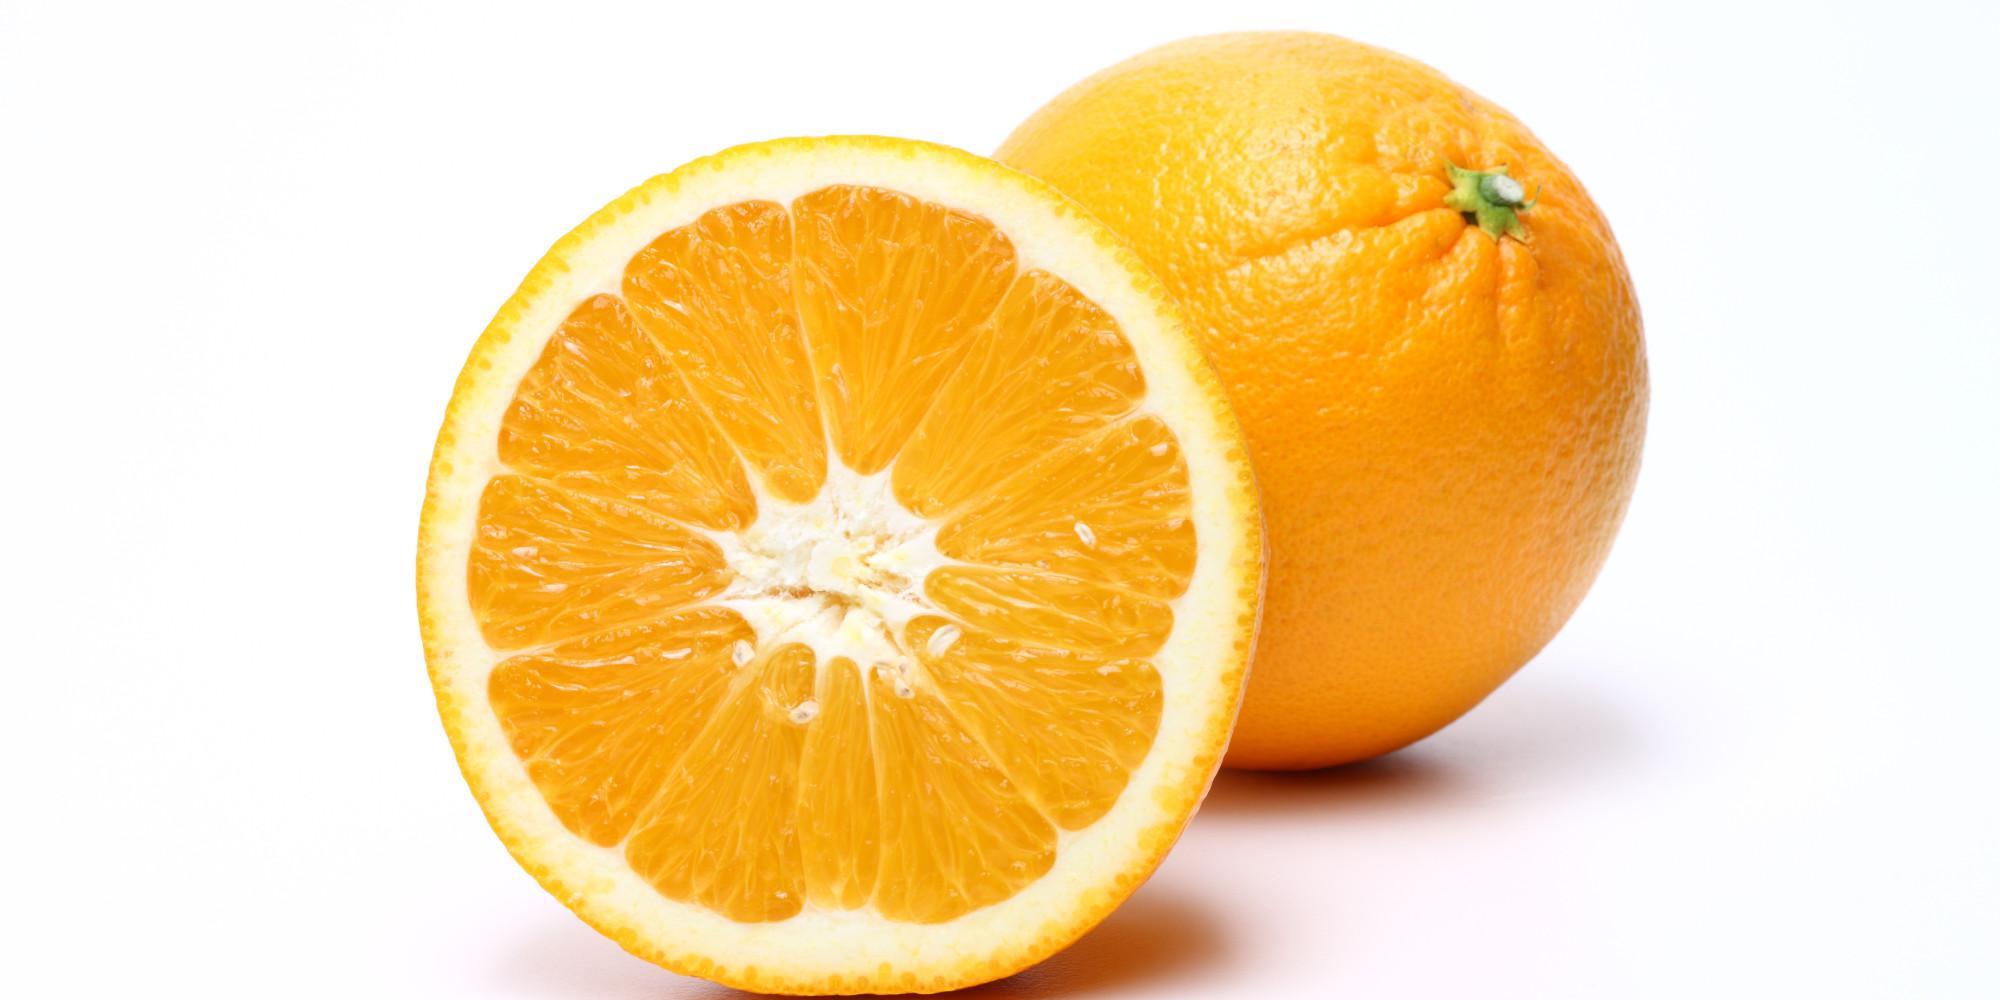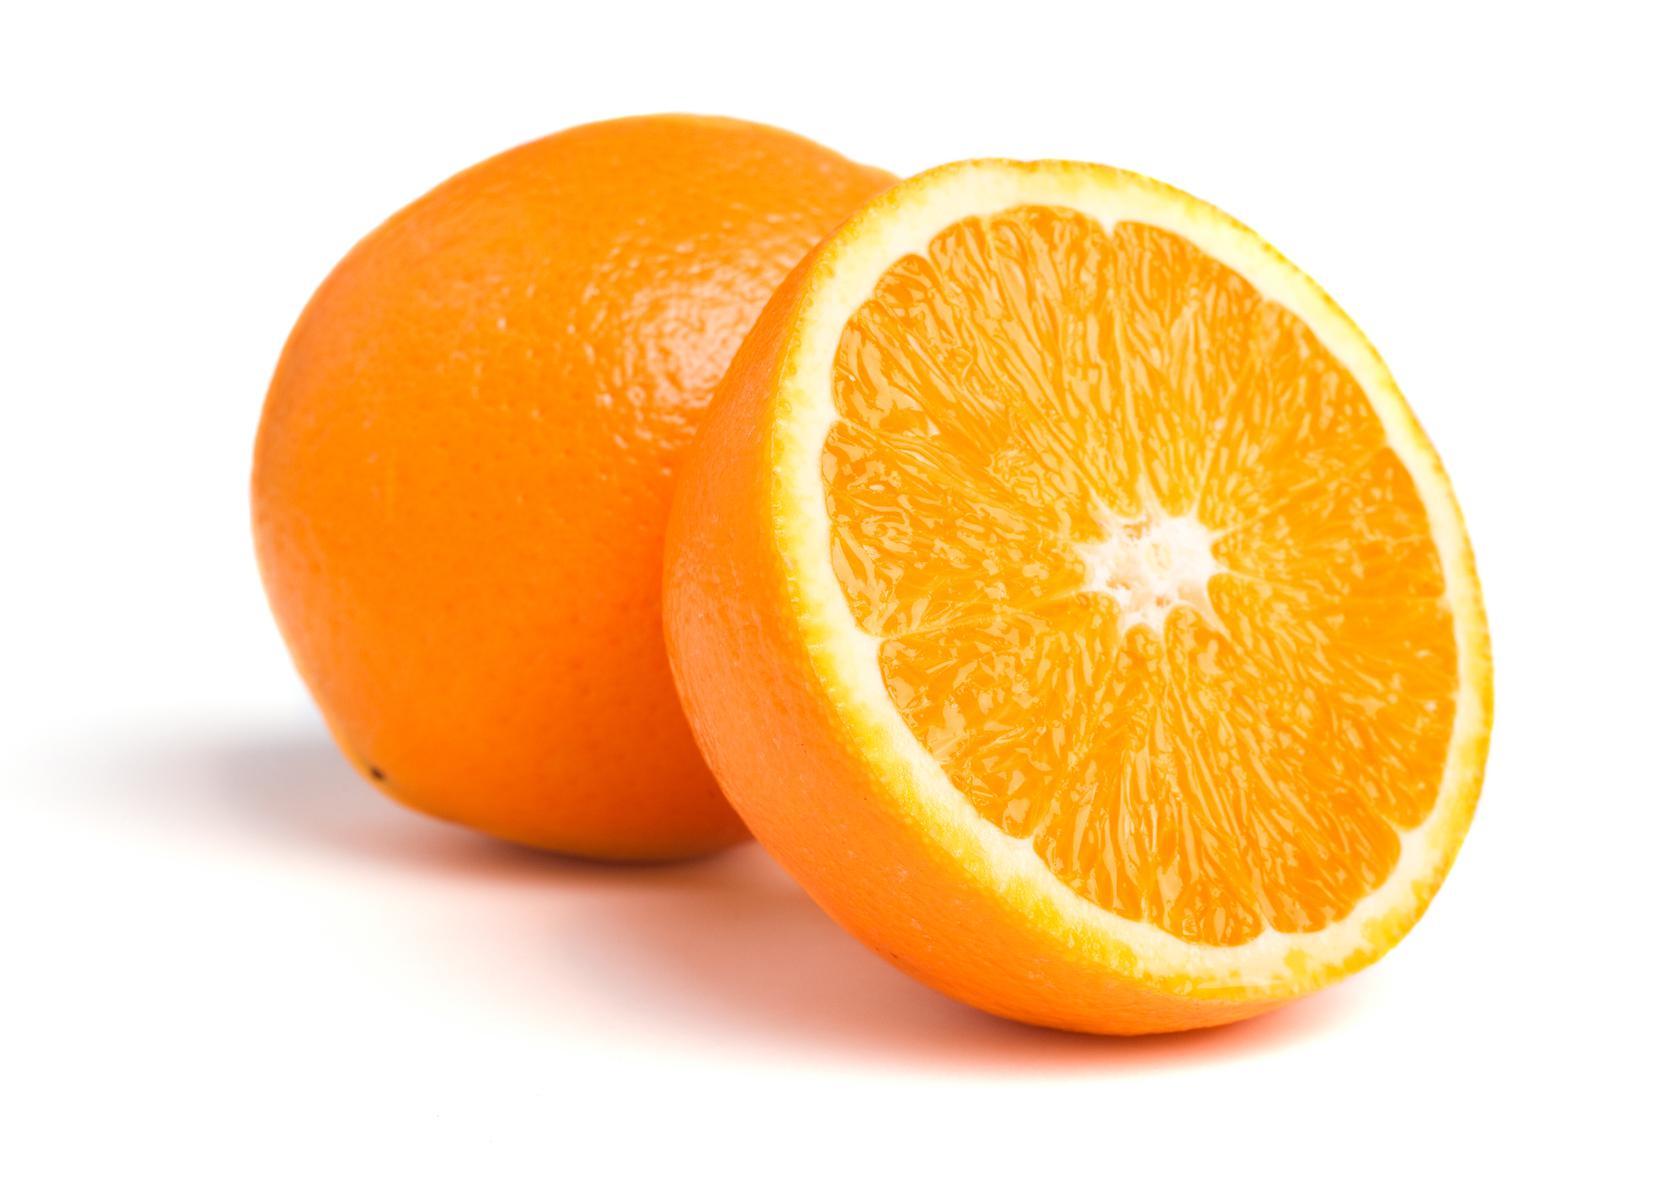The first image is the image on the left, the second image is the image on the right. Analyze the images presented: Is the assertion "An orange has been sliced into halves" valid? Answer yes or no. Yes. The first image is the image on the left, the second image is the image on the right. Examine the images to the left and right. Is the description "There is at least one half of an orange along with other oranges." accurate? Answer yes or no. Yes. 